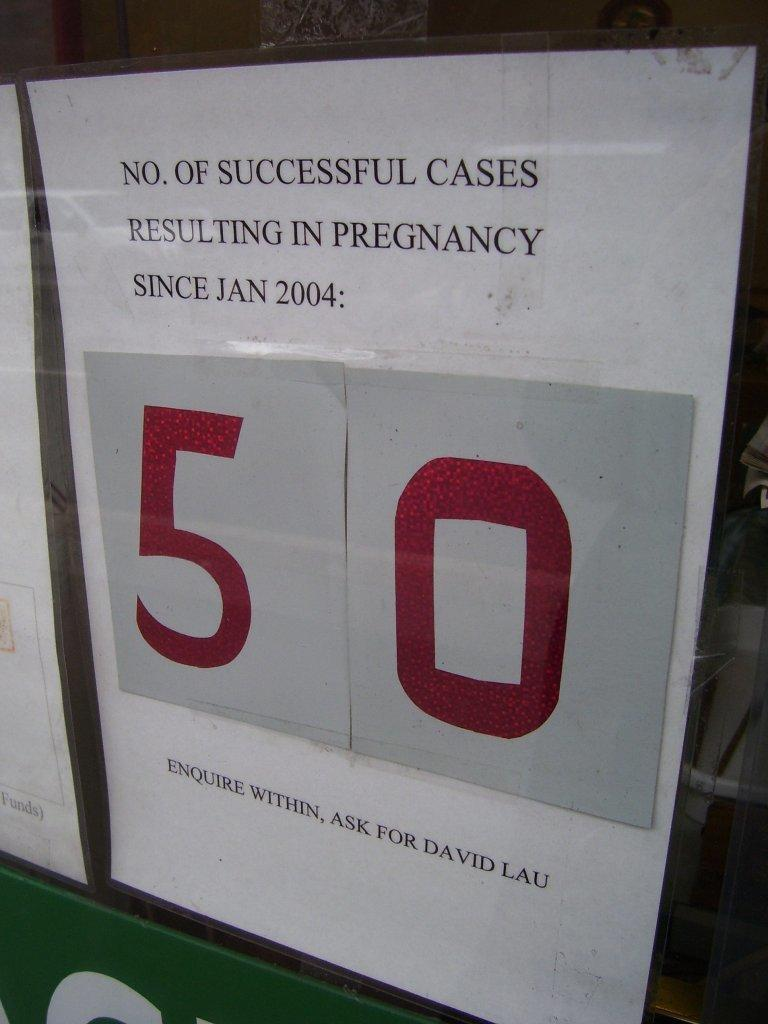<image>
Summarize the visual content of the image. A sign stating 50 is the number of successful cases resulting in pregnancy since January 2004. 